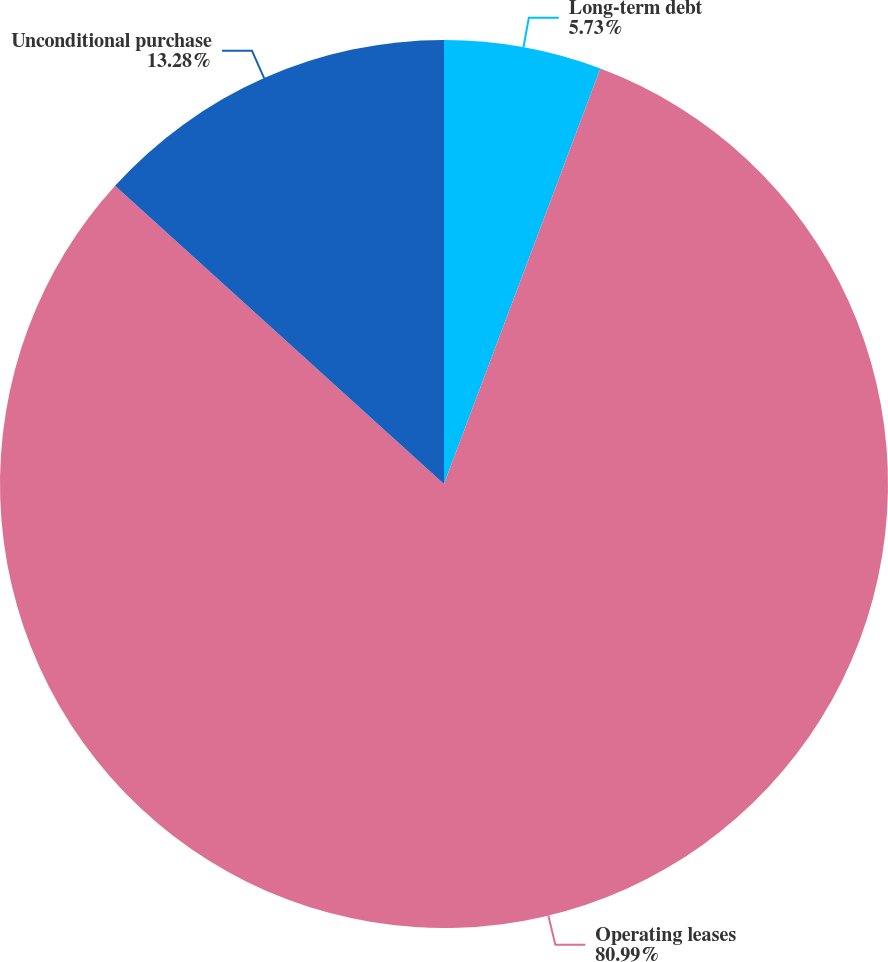<chart> <loc_0><loc_0><loc_500><loc_500><pie_chart><fcel>Long-term debt<fcel>Operating leases<fcel>Unconditional purchase<nl><fcel>5.73%<fcel>81.0%<fcel>13.28%<nl></chart> 